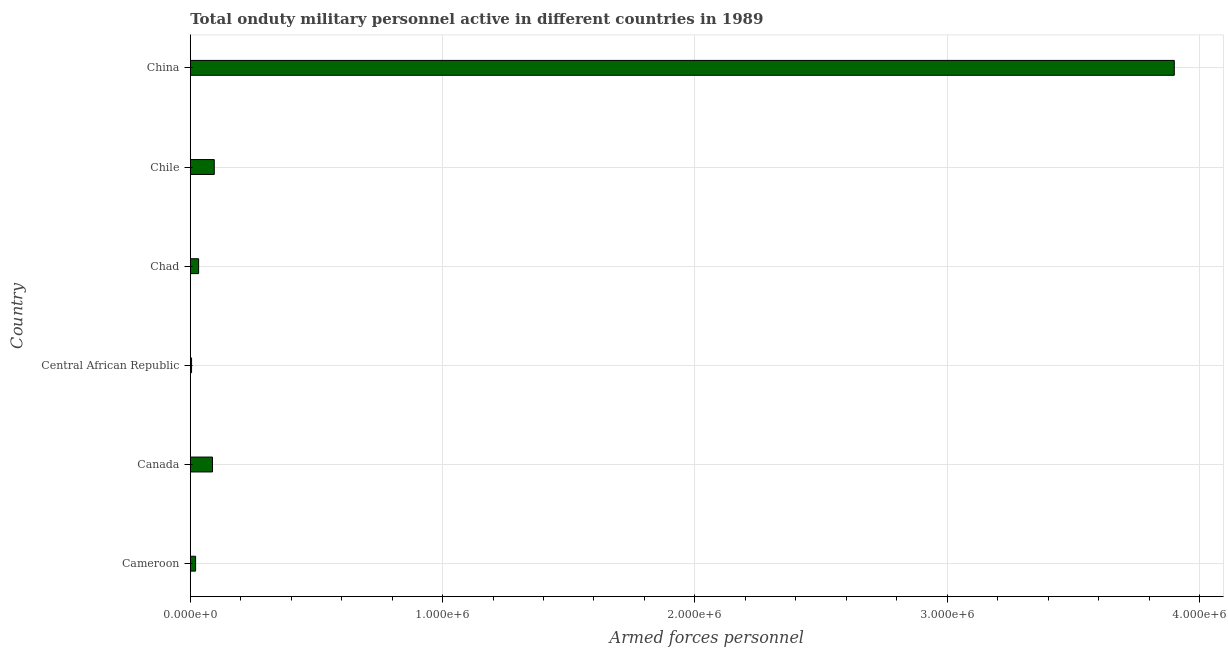Does the graph contain grids?
Your answer should be very brief. Yes. What is the title of the graph?
Keep it short and to the point. Total onduty military personnel active in different countries in 1989. What is the label or title of the X-axis?
Ensure brevity in your answer.  Armed forces personnel. What is the label or title of the Y-axis?
Your response must be concise. Country. Across all countries, what is the maximum number of armed forces personnel?
Your response must be concise. 3.90e+06. In which country was the number of armed forces personnel maximum?
Give a very brief answer. China. In which country was the number of armed forces personnel minimum?
Your response must be concise. Central African Republic. What is the sum of the number of armed forces personnel?
Your answer should be very brief. 4.14e+06. What is the difference between the number of armed forces personnel in Canada and China?
Provide a succinct answer. -3.81e+06. What is the average number of armed forces personnel per country?
Offer a terse response. 6.90e+05. What is the median number of armed forces personnel?
Give a very brief answer. 6.05e+04. In how many countries, is the number of armed forces personnel greater than 1800000 ?
Provide a succinct answer. 1. What is the ratio of the number of armed forces personnel in Central African Republic to that in China?
Offer a very short reply. 0. What is the difference between the highest and the second highest number of armed forces personnel?
Offer a terse response. 3.80e+06. Is the sum of the number of armed forces personnel in Cameroon and Chile greater than the maximum number of armed forces personnel across all countries?
Provide a short and direct response. No. What is the difference between the highest and the lowest number of armed forces personnel?
Give a very brief answer. 3.90e+06. How many bars are there?
Offer a very short reply. 6. Are the values on the major ticks of X-axis written in scientific E-notation?
Offer a terse response. Yes. What is the Armed forces personnel in Cameroon?
Give a very brief answer. 2.10e+04. What is the Armed forces personnel in Canada?
Provide a short and direct response. 8.80e+04. What is the Armed forces personnel of Central African Republic?
Offer a very short reply. 5000. What is the Armed forces personnel of Chad?
Provide a succinct answer. 3.30e+04. What is the Armed forces personnel of Chile?
Your answer should be very brief. 9.50e+04. What is the Armed forces personnel of China?
Offer a very short reply. 3.90e+06. What is the difference between the Armed forces personnel in Cameroon and Canada?
Your response must be concise. -6.70e+04. What is the difference between the Armed forces personnel in Cameroon and Central African Republic?
Your response must be concise. 1.60e+04. What is the difference between the Armed forces personnel in Cameroon and Chad?
Provide a short and direct response. -1.20e+04. What is the difference between the Armed forces personnel in Cameroon and Chile?
Offer a very short reply. -7.40e+04. What is the difference between the Armed forces personnel in Cameroon and China?
Give a very brief answer. -3.88e+06. What is the difference between the Armed forces personnel in Canada and Central African Republic?
Make the answer very short. 8.30e+04. What is the difference between the Armed forces personnel in Canada and Chad?
Keep it short and to the point. 5.50e+04. What is the difference between the Armed forces personnel in Canada and Chile?
Offer a very short reply. -7000. What is the difference between the Armed forces personnel in Canada and China?
Your answer should be very brief. -3.81e+06. What is the difference between the Armed forces personnel in Central African Republic and Chad?
Ensure brevity in your answer.  -2.80e+04. What is the difference between the Armed forces personnel in Central African Republic and Chile?
Make the answer very short. -9.00e+04. What is the difference between the Armed forces personnel in Central African Republic and China?
Offer a very short reply. -3.90e+06. What is the difference between the Armed forces personnel in Chad and Chile?
Ensure brevity in your answer.  -6.20e+04. What is the difference between the Armed forces personnel in Chad and China?
Provide a succinct answer. -3.87e+06. What is the difference between the Armed forces personnel in Chile and China?
Provide a succinct answer. -3.80e+06. What is the ratio of the Armed forces personnel in Cameroon to that in Canada?
Your response must be concise. 0.24. What is the ratio of the Armed forces personnel in Cameroon to that in Chad?
Your answer should be very brief. 0.64. What is the ratio of the Armed forces personnel in Cameroon to that in Chile?
Give a very brief answer. 0.22. What is the ratio of the Armed forces personnel in Cameroon to that in China?
Provide a succinct answer. 0.01. What is the ratio of the Armed forces personnel in Canada to that in Chad?
Ensure brevity in your answer.  2.67. What is the ratio of the Armed forces personnel in Canada to that in Chile?
Keep it short and to the point. 0.93. What is the ratio of the Armed forces personnel in Canada to that in China?
Keep it short and to the point. 0.02. What is the ratio of the Armed forces personnel in Central African Republic to that in Chad?
Offer a terse response. 0.15. What is the ratio of the Armed forces personnel in Central African Republic to that in Chile?
Offer a terse response. 0.05. What is the ratio of the Armed forces personnel in Chad to that in Chile?
Your answer should be very brief. 0.35. What is the ratio of the Armed forces personnel in Chad to that in China?
Your response must be concise. 0.01. What is the ratio of the Armed forces personnel in Chile to that in China?
Keep it short and to the point. 0.02. 